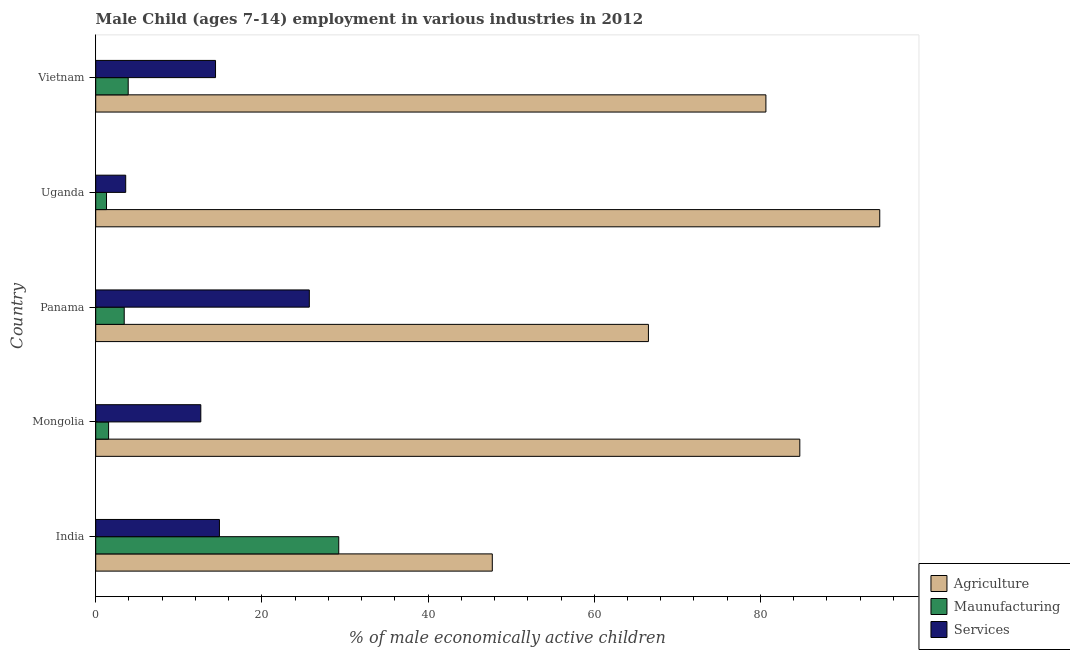How many different coloured bars are there?
Your answer should be compact. 3. How many groups of bars are there?
Provide a succinct answer. 5. Are the number of bars per tick equal to the number of legend labels?
Offer a very short reply. Yes. Are the number of bars on each tick of the Y-axis equal?
Make the answer very short. Yes. How many bars are there on the 1st tick from the top?
Provide a short and direct response. 3. What is the label of the 3rd group of bars from the top?
Make the answer very short. Panama. In how many cases, is the number of bars for a given country not equal to the number of legend labels?
Your answer should be compact. 0. Across all countries, what is the maximum percentage of economically active children in services?
Your answer should be compact. 25.71. Across all countries, what is the minimum percentage of economically active children in services?
Your answer should be compact. 3.61. In which country was the percentage of economically active children in manufacturing minimum?
Offer a terse response. Uganda. What is the total percentage of economically active children in services in the graph?
Your answer should be very brief. 71.28. What is the difference between the percentage of economically active children in services in Panama and that in Uganda?
Your response must be concise. 22.1. What is the difference between the percentage of economically active children in manufacturing in Panama and the percentage of economically active children in agriculture in Uganda?
Keep it short and to the point. -90.93. What is the average percentage of economically active children in services per country?
Offer a terse response. 14.26. What is the difference between the percentage of economically active children in agriculture and percentage of economically active children in manufacturing in Uganda?
Provide a short and direct response. 93.06. What is the ratio of the percentage of economically active children in manufacturing in Panama to that in Uganda?
Provide a short and direct response. 2.64. Is the percentage of economically active children in services in India less than that in Panama?
Your answer should be compact. Yes. Is the difference between the percentage of economically active children in manufacturing in India and Mongolia greater than the difference between the percentage of economically active children in agriculture in India and Mongolia?
Provide a succinct answer. Yes. What is the difference between the highest and the second highest percentage of economically active children in services?
Your answer should be very brief. 10.82. What is the difference between the highest and the lowest percentage of economically active children in agriculture?
Provide a succinct answer. 46.63. What does the 3rd bar from the top in Mongolia represents?
Offer a very short reply. Agriculture. What does the 3rd bar from the bottom in Uganda represents?
Keep it short and to the point. Services. Is it the case that in every country, the sum of the percentage of economically active children in agriculture and percentage of economically active children in manufacturing is greater than the percentage of economically active children in services?
Provide a short and direct response. Yes. Are all the bars in the graph horizontal?
Keep it short and to the point. Yes. Are the values on the major ticks of X-axis written in scientific E-notation?
Make the answer very short. No. Does the graph contain any zero values?
Your answer should be very brief. No. What is the title of the graph?
Offer a very short reply. Male Child (ages 7-14) employment in various industries in 2012. What is the label or title of the X-axis?
Your answer should be compact. % of male economically active children. What is the label or title of the Y-axis?
Your response must be concise. Country. What is the % of male economically active children in Agriculture in India?
Keep it short and to the point. 47.73. What is the % of male economically active children in Maunufacturing in India?
Make the answer very short. 29.25. What is the % of male economically active children in Services in India?
Your answer should be compact. 14.89. What is the % of male economically active children of Agriculture in Mongolia?
Keep it short and to the point. 84.74. What is the % of male economically active children of Maunufacturing in Mongolia?
Offer a terse response. 1.55. What is the % of male economically active children in Services in Mongolia?
Offer a terse response. 12.65. What is the % of male economically active children of Agriculture in Panama?
Your answer should be very brief. 66.52. What is the % of male economically active children of Maunufacturing in Panama?
Your answer should be very brief. 3.43. What is the % of male economically active children of Services in Panama?
Keep it short and to the point. 25.71. What is the % of male economically active children in Agriculture in Uganda?
Ensure brevity in your answer.  94.36. What is the % of male economically active children of Maunufacturing in Uganda?
Your answer should be very brief. 1.3. What is the % of male economically active children of Services in Uganda?
Your response must be concise. 3.61. What is the % of male economically active children in Agriculture in Vietnam?
Provide a short and direct response. 80.66. What is the % of male economically active children in Maunufacturing in Vietnam?
Ensure brevity in your answer.  3.91. What is the % of male economically active children of Services in Vietnam?
Provide a succinct answer. 14.42. Across all countries, what is the maximum % of male economically active children of Agriculture?
Your answer should be compact. 94.36. Across all countries, what is the maximum % of male economically active children in Maunufacturing?
Your answer should be very brief. 29.25. Across all countries, what is the maximum % of male economically active children of Services?
Offer a terse response. 25.71. Across all countries, what is the minimum % of male economically active children of Agriculture?
Your answer should be very brief. 47.73. Across all countries, what is the minimum % of male economically active children of Services?
Make the answer very short. 3.61. What is the total % of male economically active children in Agriculture in the graph?
Your answer should be very brief. 374.01. What is the total % of male economically active children in Maunufacturing in the graph?
Offer a terse response. 39.44. What is the total % of male economically active children in Services in the graph?
Provide a succinct answer. 71.28. What is the difference between the % of male economically active children of Agriculture in India and that in Mongolia?
Offer a terse response. -37.01. What is the difference between the % of male economically active children in Maunufacturing in India and that in Mongolia?
Your response must be concise. 27.7. What is the difference between the % of male economically active children of Services in India and that in Mongolia?
Your answer should be very brief. 2.24. What is the difference between the % of male economically active children in Agriculture in India and that in Panama?
Offer a very short reply. -18.79. What is the difference between the % of male economically active children of Maunufacturing in India and that in Panama?
Give a very brief answer. 25.82. What is the difference between the % of male economically active children of Services in India and that in Panama?
Offer a terse response. -10.82. What is the difference between the % of male economically active children of Agriculture in India and that in Uganda?
Provide a short and direct response. -46.63. What is the difference between the % of male economically active children in Maunufacturing in India and that in Uganda?
Provide a succinct answer. 27.95. What is the difference between the % of male economically active children in Services in India and that in Uganda?
Ensure brevity in your answer.  11.28. What is the difference between the % of male economically active children of Agriculture in India and that in Vietnam?
Provide a succinct answer. -32.93. What is the difference between the % of male economically active children in Maunufacturing in India and that in Vietnam?
Give a very brief answer. 25.34. What is the difference between the % of male economically active children of Services in India and that in Vietnam?
Provide a succinct answer. 0.47. What is the difference between the % of male economically active children in Agriculture in Mongolia and that in Panama?
Your response must be concise. 18.22. What is the difference between the % of male economically active children in Maunufacturing in Mongolia and that in Panama?
Your answer should be very brief. -1.88. What is the difference between the % of male economically active children of Services in Mongolia and that in Panama?
Make the answer very short. -13.06. What is the difference between the % of male economically active children of Agriculture in Mongolia and that in Uganda?
Keep it short and to the point. -9.62. What is the difference between the % of male economically active children in Maunufacturing in Mongolia and that in Uganda?
Give a very brief answer. 0.25. What is the difference between the % of male economically active children of Services in Mongolia and that in Uganda?
Your answer should be compact. 9.04. What is the difference between the % of male economically active children of Agriculture in Mongolia and that in Vietnam?
Offer a terse response. 4.08. What is the difference between the % of male economically active children of Maunufacturing in Mongolia and that in Vietnam?
Your response must be concise. -2.36. What is the difference between the % of male economically active children of Services in Mongolia and that in Vietnam?
Your answer should be very brief. -1.77. What is the difference between the % of male economically active children in Agriculture in Panama and that in Uganda?
Offer a very short reply. -27.84. What is the difference between the % of male economically active children of Maunufacturing in Panama and that in Uganda?
Your answer should be compact. 2.13. What is the difference between the % of male economically active children of Services in Panama and that in Uganda?
Give a very brief answer. 22.1. What is the difference between the % of male economically active children of Agriculture in Panama and that in Vietnam?
Provide a short and direct response. -14.14. What is the difference between the % of male economically active children of Maunufacturing in Panama and that in Vietnam?
Keep it short and to the point. -0.48. What is the difference between the % of male economically active children of Services in Panama and that in Vietnam?
Your response must be concise. 11.29. What is the difference between the % of male economically active children in Agriculture in Uganda and that in Vietnam?
Offer a very short reply. 13.7. What is the difference between the % of male economically active children in Maunufacturing in Uganda and that in Vietnam?
Your answer should be compact. -2.61. What is the difference between the % of male economically active children in Services in Uganda and that in Vietnam?
Your answer should be very brief. -10.81. What is the difference between the % of male economically active children in Agriculture in India and the % of male economically active children in Maunufacturing in Mongolia?
Keep it short and to the point. 46.18. What is the difference between the % of male economically active children of Agriculture in India and the % of male economically active children of Services in Mongolia?
Give a very brief answer. 35.08. What is the difference between the % of male economically active children in Agriculture in India and the % of male economically active children in Maunufacturing in Panama?
Offer a terse response. 44.3. What is the difference between the % of male economically active children of Agriculture in India and the % of male economically active children of Services in Panama?
Offer a terse response. 22.02. What is the difference between the % of male economically active children in Maunufacturing in India and the % of male economically active children in Services in Panama?
Offer a terse response. 3.54. What is the difference between the % of male economically active children in Agriculture in India and the % of male economically active children in Maunufacturing in Uganda?
Provide a short and direct response. 46.43. What is the difference between the % of male economically active children of Agriculture in India and the % of male economically active children of Services in Uganda?
Make the answer very short. 44.12. What is the difference between the % of male economically active children in Maunufacturing in India and the % of male economically active children in Services in Uganda?
Provide a short and direct response. 25.64. What is the difference between the % of male economically active children of Agriculture in India and the % of male economically active children of Maunufacturing in Vietnam?
Give a very brief answer. 43.82. What is the difference between the % of male economically active children in Agriculture in India and the % of male economically active children in Services in Vietnam?
Provide a succinct answer. 33.31. What is the difference between the % of male economically active children in Maunufacturing in India and the % of male economically active children in Services in Vietnam?
Offer a very short reply. 14.83. What is the difference between the % of male economically active children in Agriculture in Mongolia and the % of male economically active children in Maunufacturing in Panama?
Your answer should be compact. 81.31. What is the difference between the % of male economically active children in Agriculture in Mongolia and the % of male economically active children in Services in Panama?
Provide a succinct answer. 59.03. What is the difference between the % of male economically active children of Maunufacturing in Mongolia and the % of male economically active children of Services in Panama?
Give a very brief answer. -24.16. What is the difference between the % of male economically active children of Agriculture in Mongolia and the % of male economically active children of Maunufacturing in Uganda?
Offer a very short reply. 83.44. What is the difference between the % of male economically active children of Agriculture in Mongolia and the % of male economically active children of Services in Uganda?
Keep it short and to the point. 81.13. What is the difference between the % of male economically active children in Maunufacturing in Mongolia and the % of male economically active children in Services in Uganda?
Offer a very short reply. -2.06. What is the difference between the % of male economically active children in Agriculture in Mongolia and the % of male economically active children in Maunufacturing in Vietnam?
Ensure brevity in your answer.  80.83. What is the difference between the % of male economically active children of Agriculture in Mongolia and the % of male economically active children of Services in Vietnam?
Offer a terse response. 70.32. What is the difference between the % of male economically active children of Maunufacturing in Mongolia and the % of male economically active children of Services in Vietnam?
Offer a very short reply. -12.87. What is the difference between the % of male economically active children of Agriculture in Panama and the % of male economically active children of Maunufacturing in Uganda?
Offer a terse response. 65.22. What is the difference between the % of male economically active children of Agriculture in Panama and the % of male economically active children of Services in Uganda?
Provide a short and direct response. 62.91. What is the difference between the % of male economically active children of Maunufacturing in Panama and the % of male economically active children of Services in Uganda?
Your answer should be very brief. -0.18. What is the difference between the % of male economically active children of Agriculture in Panama and the % of male economically active children of Maunufacturing in Vietnam?
Your answer should be compact. 62.61. What is the difference between the % of male economically active children in Agriculture in Panama and the % of male economically active children in Services in Vietnam?
Make the answer very short. 52.1. What is the difference between the % of male economically active children in Maunufacturing in Panama and the % of male economically active children in Services in Vietnam?
Your response must be concise. -10.99. What is the difference between the % of male economically active children in Agriculture in Uganda and the % of male economically active children in Maunufacturing in Vietnam?
Give a very brief answer. 90.45. What is the difference between the % of male economically active children in Agriculture in Uganda and the % of male economically active children in Services in Vietnam?
Offer a terse response. 79.94. What is the difference between the % of male economically active children of Maunufacturing in Uganda and the % of male economically active children of Services in Vietnam?
Provide a succinct answer. -13.12. What is the average % of male economically active children in Agriculture per country?
Your answer should be compact. 74.8. What is the average % of male economically active children in Maunufacturing per country?
Ensure brevity in your answer.  7.89. What is the average % of male economically active children of Services per country?
Offer a very short reply. 14.26. What is the difference between the % of male economically active children in Agriculture and % of male economically active children in Maunufacturing in India?
Keep it short and to the point. 18.48. What is the difference between the % of male economically active children in Agriculture and % of male economically active children in Services in India?
Offer a very short reply. 32.84. What is the difference between the % of male economically active children of Maunufacturing and % of male economically active children of Services in India?
Make the answer very short. 14.36. What is the difference between the % of male economically active children in Agriculture and % of male economically active children in Maunufacturing in Mongolia?
Provide a short and direct response. 83.19. What is the difference between the % of male economically active children in Agriculture and % of male economically active children in Services in Mongolia?
Give a very brief answer. 72.09. What is the difference between the % of male economically active children in Agriculture and % of male economically active children in Maunufacturing in Panama?
Make the answer very short. 63.09. What is the difference between the % of male economically active children of Agriculture and % of male economically active children of Services in Panama?
Offer a very short reply. 40.81. What is the difference between the % of male economically active children in Maunufacturing and % of male economically active children in Services in Panama?
Ensure brevity in your answer.  -22.28. What is the difference between the % of male economically active children in Agriculture and % of male economically active children in Maunufacturing in Uganda?
Provide a succinct answer. 93.06. What is the difference between the % of male economically active children of Agriculture and % of male economically active children of Services in Uganda?
Keep it short and to the point. 90.75. What is the difference between the % of male economically active children in Maunufacturing and % of male economically active children in Services in Uganda?
Provide a succinct answer. -2.31. What is the difference between the % of male economically active children of Agriculture and % of male economically active children of Maunufacturing in Vietnam?
Your answer should be compact. 76.75. What is the difference between the % of male economically active children in Agriculture and % of male economically active children in Services in Vietnam?
Offer a very short reply. 66.24. What is the difference between the % of male economically active children in Maunufacturing and % of male economically active children in Services in Vietnam?
Your answer should be very brief. -10.51. What is the ratio of the % of male economically active children in Agriculture in India to that in Mongolia?
Your response must be concise. 0.56. What is the ratio of the % of male economically active children in Maunufacturing in India to that in Mongolia?
Your response must be concise. 18.87. What is the ratio of the % of male economically active children of Services in India to that in Mongolia?
Give a very brief answer. 1.18. What is the ratio of the % of male economically active children of Agriculture in India to that in Panama?
Keep it short and to the point. 0.72. What is the ratio of the % of male economically active children of Maunufacturing in India to that in Panama?
Ensure brevity in your answer.  8.53. What is the ratio of the % of male economically active children in Services in India to that in Panama?
Your response must be concise. 0.58. What is the ratio of the % of male economically active children of Agriculture in India to that in Uganda?
Provide a succinct answer. 0.51. What is the ratio of the % of male economically active children in Maunufacturing in India to that in Uganda?
Your response must be concise. 22.5. What is the ratio of the % of male economically active children of Services in India to that in Uganda?
Your response must be concise. 4.12. What is the ratio of the % of male economically active children of Agriculture in India to that in Vietnam?
Offer a very short reply. 0.59. What is the ratio of the % of male economically active children in Maunufacturing in India to that in Vietnam?
Provide a succinct answer. 7.48. What is the ratio of the % of male economically active children in Services in India to that in Vietnam?
Ensure brevity in your answer.  1.03. What is the ratio of the % of male economically active children of Agriculture in Mongolia to that in Panama?
Offer a very short reply. 1.27. What is the ratio of the % of male economically active children of Maunufacturing in Mongolia to that in Panama?
Offer a terse response. 0.45. What is the ratio of the % of male economically active children of Services in Mongolia to that in Panama?
Ensure brevity in your answer.  0.49. What is the ratio of the % of male economically active children in Agriculture in Mongolia to that in Uganda?
Ensure brevity in your answer.  0.9. What is the ratio of the % of male economically active children in Maunufacturing in Mongolia to that in Uganda?
Offer a terse response. 1.19. What is the ratio of the % of male economically active children in Services in Mongolia to that in Uganda?
Your answer should be very brief. 3.5. What is the ratio of the % of male economically active children in Agriculture in Mongolia to that in Vietnam?
Make the answer very short. 1.05. What is the ratio of the % of male economically active children of Maunufacturing in Mongolia to that in Vietnam?
Your answer should be very brief. 0.4. What is the ratio of the % of male economically active children in Services in Mongolia to that in Vietnam?
Offer a terse response. 0.88. What is the ratio of the % of male economically active children in Agriculture in Panama to that in Uganda?
Your response must be concise. 0.7. What is the ratio of the % of male economically active children in Maunufacturing in Panama to that in Uganda?
Provide a succinct answer. 2.64. What is the ratio of the % of male economically active children in Services in Panama to that in Uganda?
Offer a terse response. 7.12. What is the ratio of the % of male economically active children in Agriculture in Panama to that in Vietnam?
Ensure brevity in your answer.  0.82. What is the ratio of the % of male economically active children of Maunufacturing in Panama to that in Vietnam?
Give a very brief answer. 0.88. What is the ratio of the % of male economically active children of Services in Panama to that in Vietnam?
Provide a succinct answer. 1.78. What is the ratio of the % of male economically active children in Agriculture in Uganda to that in Vietnam?
Provide a short and direct response. 1.17. What is the ratio of the % of male economically active children in Maunufacturing in Uganda to that in Vietnam?
Your answer should be compact. 0.33. What is the ratio of the % of male economically active children in Services in Uganda to that in Vietnam?
Keep it short and to the point. 0.25. What is the difference between the highest and the second highest % of male economically active children in Agriculture?
Make the answer very short. 9.62. What is the difference between the highest and the second highest % of male economically active children in Maunufacturing?
Provide a succinct answer. 25.34. What is the difference between the highest and the second highest % of male economically active children of Services?
Make the answer very short. 10.82. What is the difference between the highest and the lowest % of male economically active children of Agriculture?
Provide a short and direct response. 46.63. What is the difference between the highest and the lowest % of male economically active children in Maunufacturing?
Ensure brevity in your answer.  27.95. What is the difference between the highest and the lowest % of male economically active children in Services?
Your answer should be very brief. 22.1. 